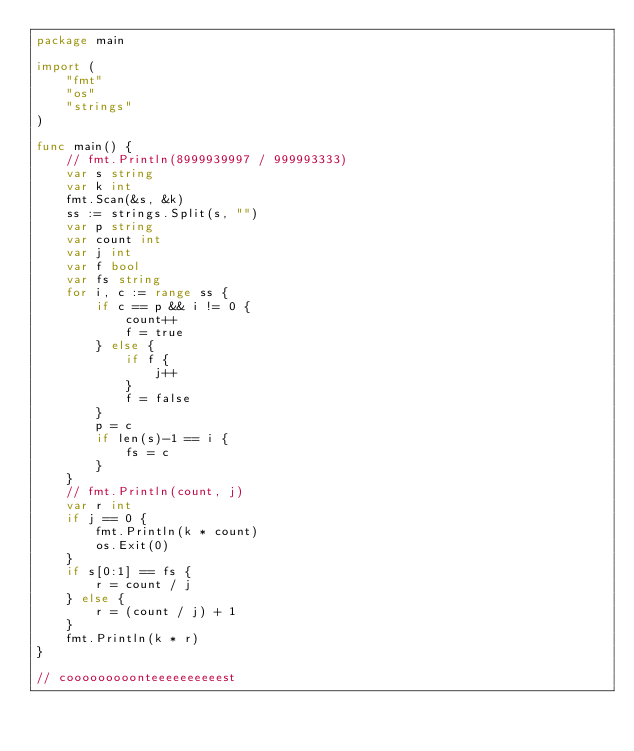Convert code to text. <code><loc_0><loc_0><loc_500><loc_500><_Go_>package main

import (
	"fmt"
	"os"
	"strings"
)

func main() {
	// fmt.Println(8999939997 / 999993333)
	var s string
	var k int
	fmt.Scan(&s, &k)
	ss := strings.Split(s, "")
	var p string
	var count int
	var j int
	var f bool
	var fs string
	for i, c := range ss {
		if c == p && i != 0 {
			count++
			f = true
		} else {
			if f {
				j++
			}
			f = false
		}
		p = c
		if len(s)-1 == i {
			fs = c
		}
	}
	// fmt.Println(count, j)
	var r int
	if j == 0 {
		fmt.Println(k * count)
		os.Exit(0)
	}
	if s[0:1] == fs {
		r = count / j
	} else {
		r = (count / j) + 1
	}
	fmt.Println(k * r)
}

// cooooooooonteeeeeeeeeest
</code> 